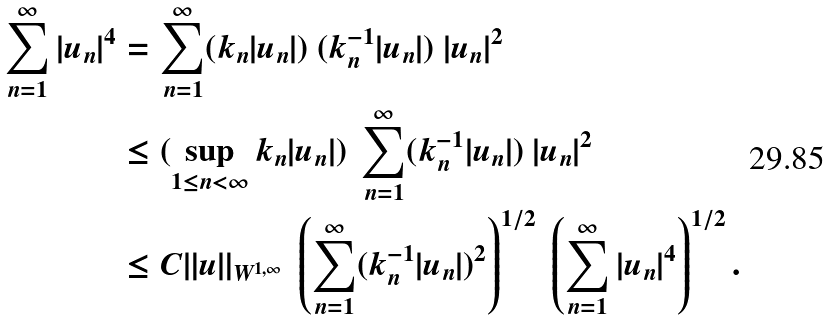<formula> <loc_0><loc_0><loc_500><loc_500>\sum _ { n = 1 } ^ { \infty } | u _ { n } | ^ { 4 } & = \sum _ { n = 1 } ^ { \infty } ( k _ { n } | u _ { n } | ) \ ( k _ { n } ^ { - 1 } | u _ { n } | ) \ | u _ { n } | ^ { 2 } \\ & \leq ( \sup _ { 1 \leq n < \infty } k _ { n } | u _ { n } | ) \ \sum _ { n = 1 } ^ { \infty } ( k _ { n } ^ { - 1 } | u _ { n } | ) \ | u _ { n } | ^ { 2 } \\ & \leq C \| u \| _ { W ^ { 1 , \infty } } \ \left ( \sum _ { n = 1 } ^ { \infty } ( k _ { n } ^ { - 1 } | u _ { n } | ) ^ { 2 } \right ) ^ { 1 / 2 } \ \left ( \sum _ { n = 1 } ^ { \infty } | u _ { n } | ^ { 4 } \right ) ^ { 1 / 2 } .</formula> 